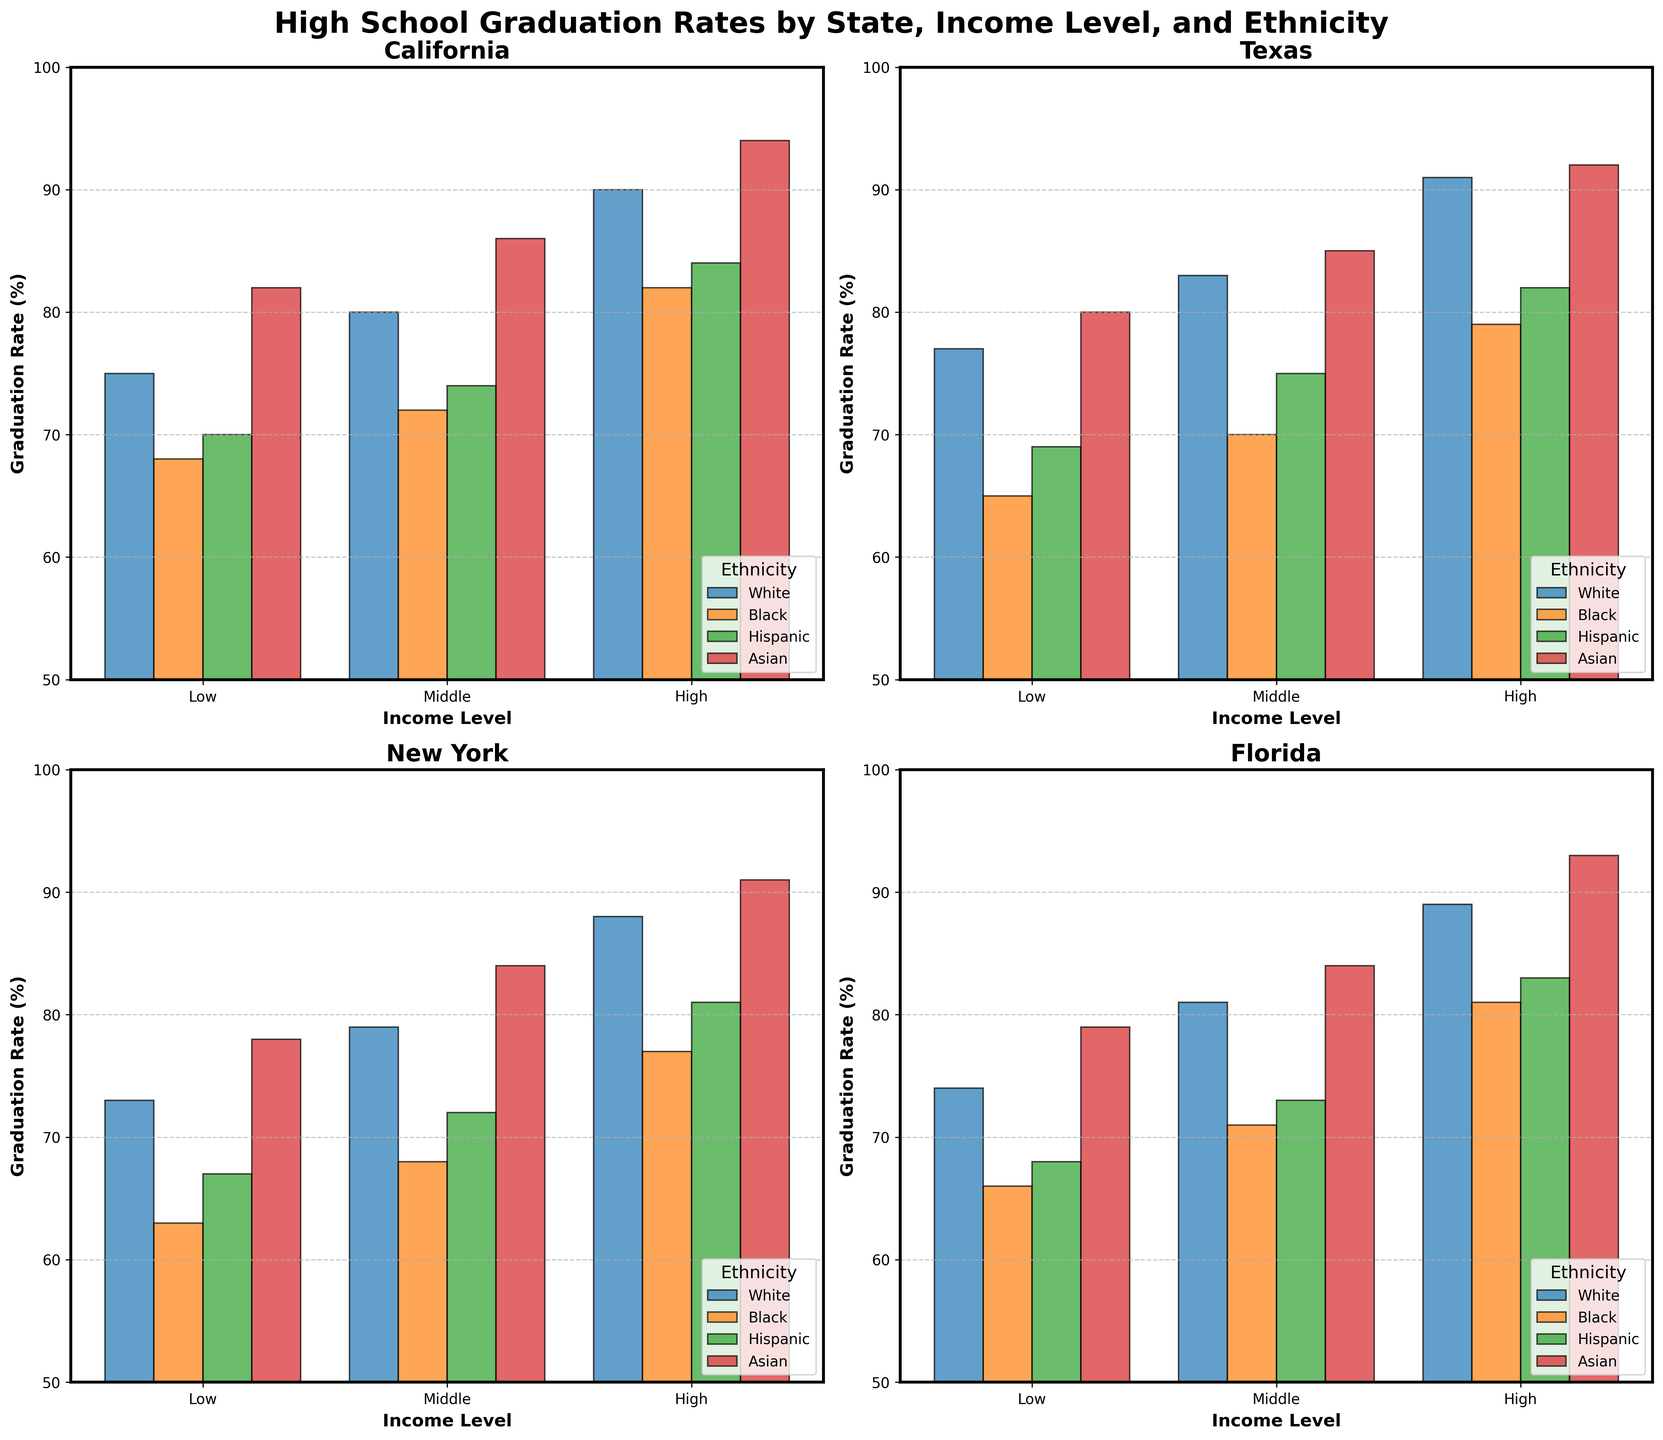What is the title of the figure? The title of the figure is located at the top center and typically provides a summary of what the figure represents. In this case, it reads "High School Graduation Rates by State, Income Level, and Ethnicity."
Answer: High School Graduation Rates by State, Income Level, and Ethnicity Which income level has the lowest graduation rate for Blacks in California? To find this, look at the California subplot and observe the bar heights for the Black ethnicity across the three income levels (Low, Middle, High). The bar with the lowest height among the three represents the lowest graduation rate.
Answer: Low How do the graduation rates of Hispanics in Texas compare between Low and High income levels? Look at the Texas subplot and compare the heights of the bars for Hispanics between the Low and High income levels. The high bar indicates a higher graduation rate.
Answer: The graduation rate is higher in High income levels Which state shows the highest graduation rate for Asians in the Low income level? Examine the bars for Asians in the Low income levels across all four state subplots. Identify which bar is the tallest.
Answer: California What is the difference in graduation rates between White students in Low and High income levels in New York? Look at the New York subplot and find the bars for White students in Low and High income levels. Subtract the height of the Low income bar from the High income bar.
Answer: 15% Does Florida show a more significant disparity in graduation rates between ethnicities at the Middle income level compared to California? Compare the range of bar heights for each ethnicity in the Middle income level for both Florida and California. A wider range indicates a more significant disparity.
Answer: Yes, Florida shows a more significant disparity For which ethnic group does the graduation rate increase the most from Middle to High income levels in Texas? In the Texas subplot, compare the bar heights between Middle and High income levels for each ethnic group. Find the ethnicity with the largest increase.
Answer: Hispanics Compare the graduation rates of Black students in High income levels across all states. Which state has the highest rate? Look at the High income level bars for Black students in all four state subplots. Identify which state's bar is the tallest.
Answer: California What trend can be observed about graduation rates across income levels for White students in all states? Analyze the bars for White students across all states and income levels. Observe whether the bars generally increase, decrease, or show no pattern as income levels rise.
Answer: Graduation rates generally increase as income levels rise Which state has the least variation in graduation rates among different ethnicities within the Low income level? To find this, observe the bars for the Low income level in each state's subplot and see which has bars of approximately equal heights, indicating minimal variation.
Answer: Florida 